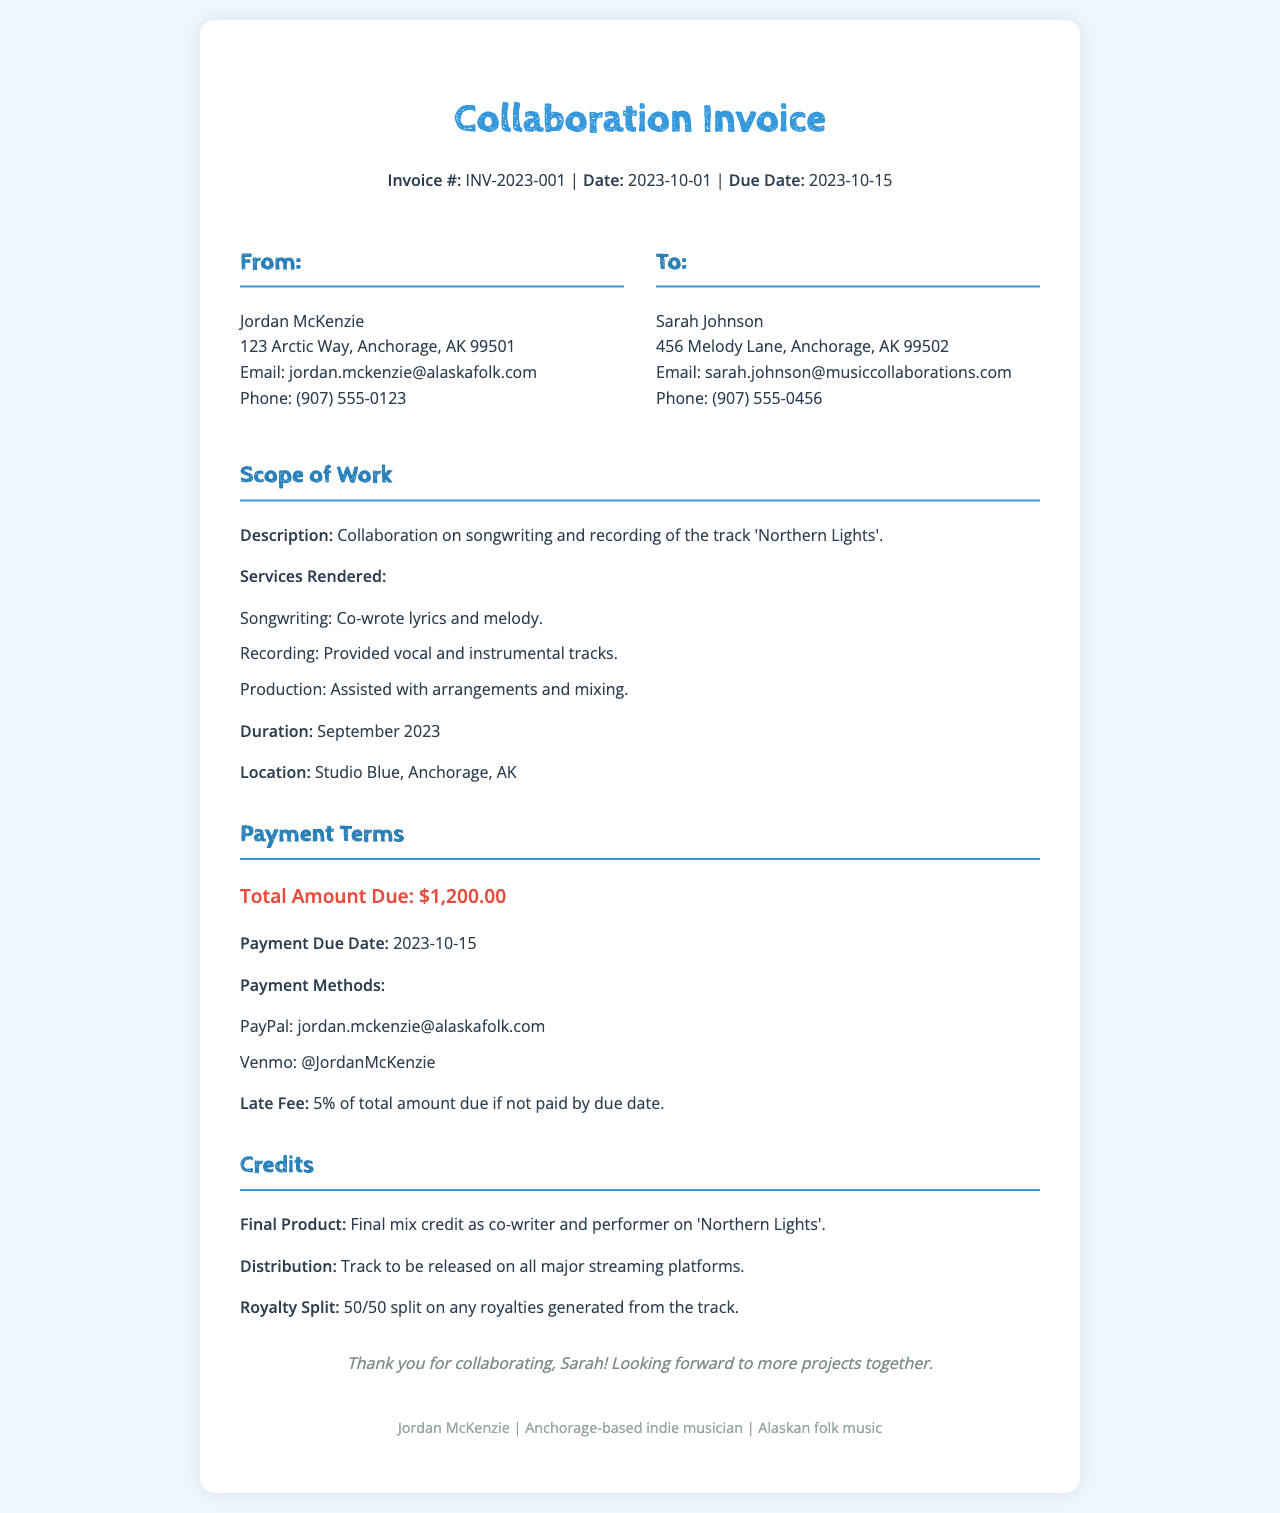What is the invoice number? The invoice number is specified in the document as INV-2023-001.
Answer: INV-2023-001 Who is the recipient of the invoice? The recipient's name is provided in the document, which is Sarah Johnson.
Answer: Sarah Johnson What is the total amount due? The total amount due is clearly stated as $1,200.00 in the payment terms section.
Answer: $1,200.00 What services were rendered? The document lists services like songwriting, recording, and production as part of the work done.
Answer: Songwriting, recording, production What is the payment due date? The document specifies the payment due date as 2023-10-15.
Answer: 2023-10-15 What is the royalty split percentage? The royalty split percentage is explicitly mentioned as a 50/50 split in the credits section.
Answer: 50/50 Where was the recording location? The recording location is mentioned in the document as Studio Blue, Anchorage, AK.
Answer: Studio Blue, Anchorage, AK What is the late fee percentage? The late fee for late payment is noted as 5% in the payment terms.
Answer: 5% What is the final product credit mentioned? The final product credit states that the individual is recognized as a co-writer and performer on 'Northern Lights'.
Answer: co-writer and performer on 'Northern Lights' What are the payment methods listed? The document lists PayPal and Venmo as payment methods.
Answer: PayPal, Venmo 